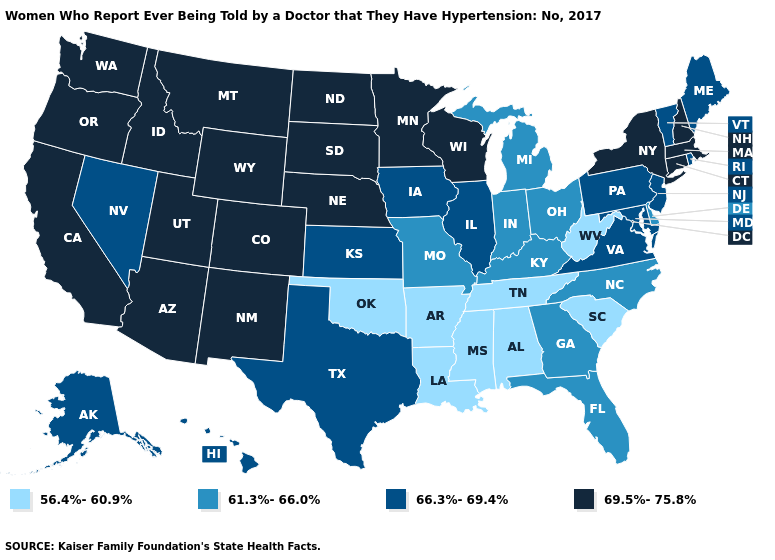Does Kentucky have the highest value in the South?
Keep it brief. No. Does the map have missing data?
Answer briefly. No. What is the value of Texas?
Write a very short answer. 66.3%-69.4%. Does New Hampshire have the highest value in the USA?
Keep it brief. Yes. Does the first symbol in the legend represent the smallest category?
Be succinct. Yes. Does Arkansas have the same value as Florida?
Write a very short answer. No. Which states hav the highest value in the MidWest?
Quick response, please. Minnesota, Nebraska, North Dakota, South Dakota, Wisconsin. Name the states that have a value in the range 66.3%-69.4%?
Give a very brief answer. Alaska, Hawaii, Illinois, Iowa, Kansas, Maine, Maryland, Nevada, New Jersey, Pennsylvania, Rhode Island, Texas, Vermont, Virginia. What is the value of Connecticut?
Concise answer only. 69.5%-75.8%. What is the lowest value in the West?
Give a very brief answer. 66.3%-69.4%. Does Kansas have the lowest value in the USA?
Keep it brief. No. Among the states that border Wisconsin , which have the highest value?
Keep it brief. Minnesota. Which states have the lowest value in the USA?
Give a very brief answer. Alabama, Arkansas, Louisiana, Mississippi, Oklahoma, South Carolina, Tennessee, West Virginia. Name the states that have a value in the range 61.3%-66.0%?
Quick response, please. Delaware, Florida, Georgia, Indiana, Kentucky, Michigan, Missouri, North Carolina, Ohio. What is the lowest value in the USA?
Quick response, please. 56.4%-60.9%. 